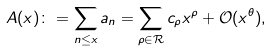Convert formula to latex. <formula><loc_0><loc_0><loc_500><loc_500>A ( x ) \colon = \sum _ { n \leq x } a _ { n } = \sum _ { \rho \in \mathcal { R } } c _ { \rho } x ^ { \rho } + \mathcal { O } ( x ^ { \theta } ) ,</formula> 